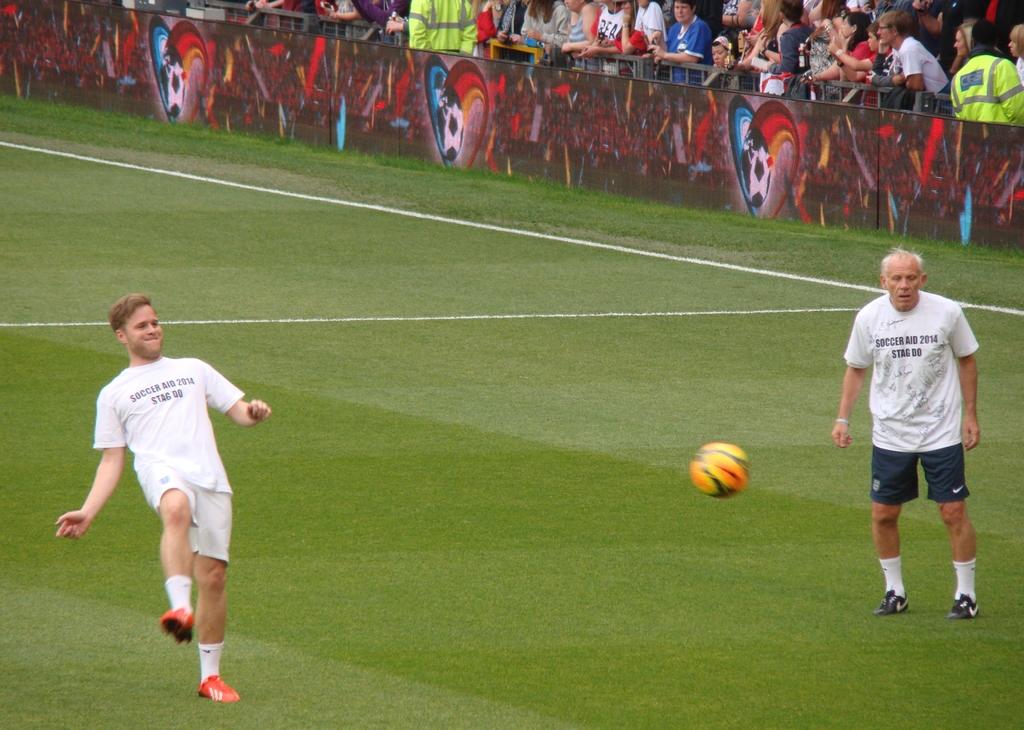What year did this take place in?
Provide a succinct answer. 2014. 